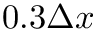Convert formula to latex. <formula><loc_0><loc_0><loc_500><loc_500>0 . 3 \Delta x</formula> 